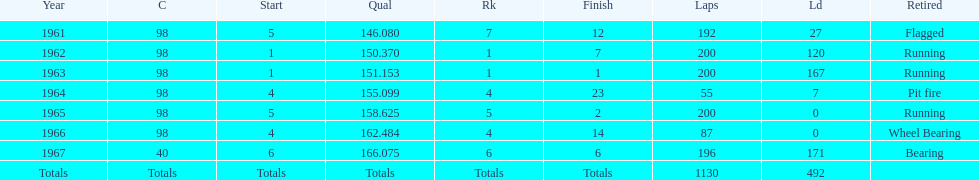How many consecutive years did parnelli place in the top 5? 5. 